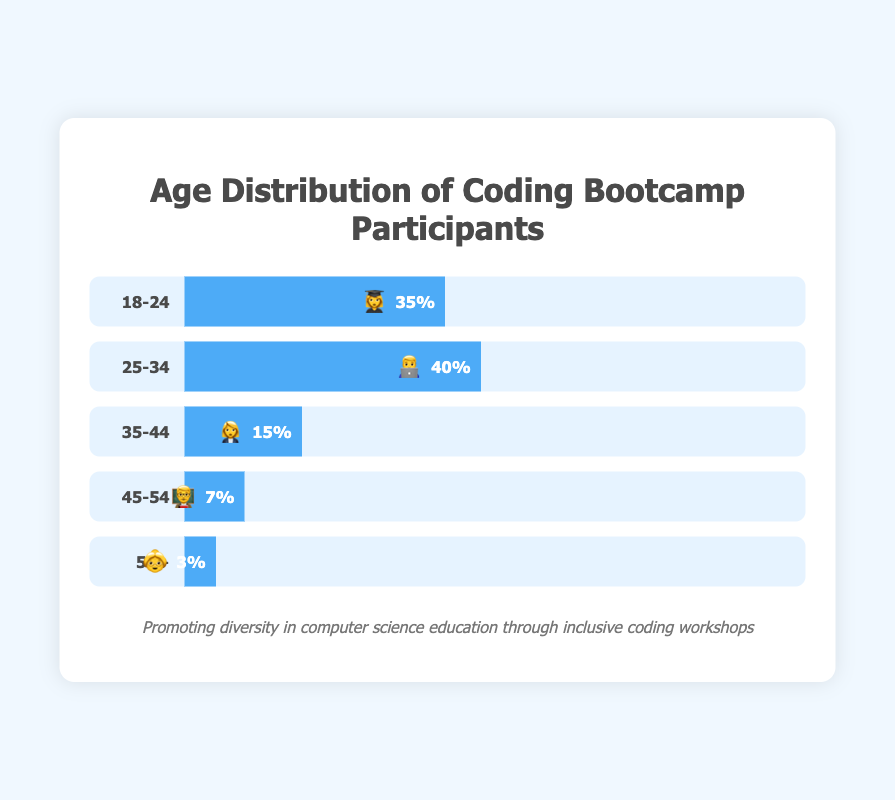What is the title of the chart? The title of the chart is displayed at the very top in bold text. It provides an overview of what the chart is representing. The title reads "Age Distribution of Coding Bootcamp Participants".
Answer: Age Distribution of Coding Bootcamp Participants Which age group has the highest percentage of participants? Looking at the labels and bar lengths, the "25-34" age group has the widest bar, which means it has the highest percentage of participants.
Answer: 25-34 What percentage of participants are aged 18-24? The bar labeled "18-24" displays the percentage within the bar itself, which is 35%. Additionally, the length of the bar also corresponds to this percentage.
Answer: 35% How do the percentages of participants aged 25-34 and 35-44 compare? The "25-34" age group has a bar with 40%, while the "35-44" age group has a bar with 15%. To compare them, we subtract the smaller percentage from the larger one. 40% - 15% = 25%.
Answer: 25% more What is the emoji used for participants aged 25-34? Each age group has an associated emoji displayed inside the bar. For the "25-34" age group, the emoji used is "👨‍💻".
Answer: 👨‍💻 What is the combined percentage of participants aged 35-44 and 45-54? The "35-44" group has 15% and "45-54" group has 7%. Adding these percentages together gives 15% + 7% = 22%.
Answer: 22% Which age group has the smallest percentage of participants? Comparing the lengths of all the bars, the "55+" age group has the smallest bar indicating the smallest percentage which is 3%.
Answer: 55+ Is there a significant difference in participation between the 18-24 (👩‍🎓) and 55+ (👵) age groups? The "18-24" group has 35%, and the "55+" group has 3%. To find the difference, subtract the smaller percentage from the larger one: 35% - 3% = 32%. Yes, there is a significant 32% difference.
Answer: Yes, 32% How does the percentage of participants aged 35-44 compare to the total percentage of participants aged 45 and older (45-54 and 55+)? The "35-44" group has 15%. The combined percentage of "45-54" and "55+" groups is 7% + 3% = 10%. 15% is 5% more than 10%.
Answer: 5% more What's the total percentage for participants aged 24 and younger and those aged 55 and older? The "18-24" group has 35% and "55+" group has 3%. Adding these together gives 35% + 3% = 38%.
Answer: 38% 